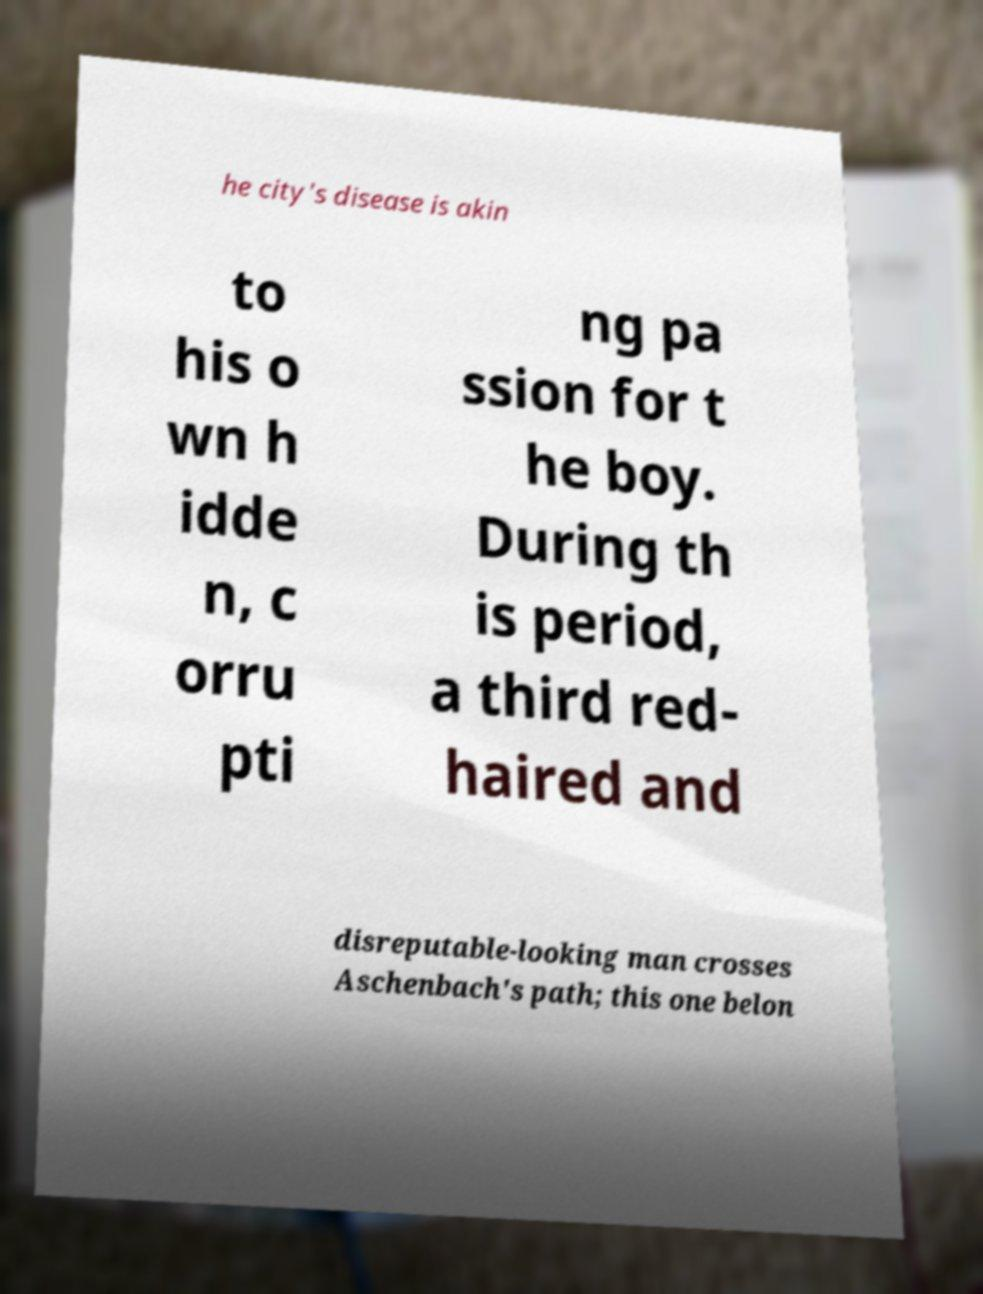Can you read and provide the text displayed in the image?This photo seems to have some interesting text. Can you extract and type it out for me? he city's disease is akin to his o wn h idde n, c orru pti ng pa ssion for t he boy. During th is period, a third red- haired and disreputable-looking man crosses Aschenbach's path; this one belon 